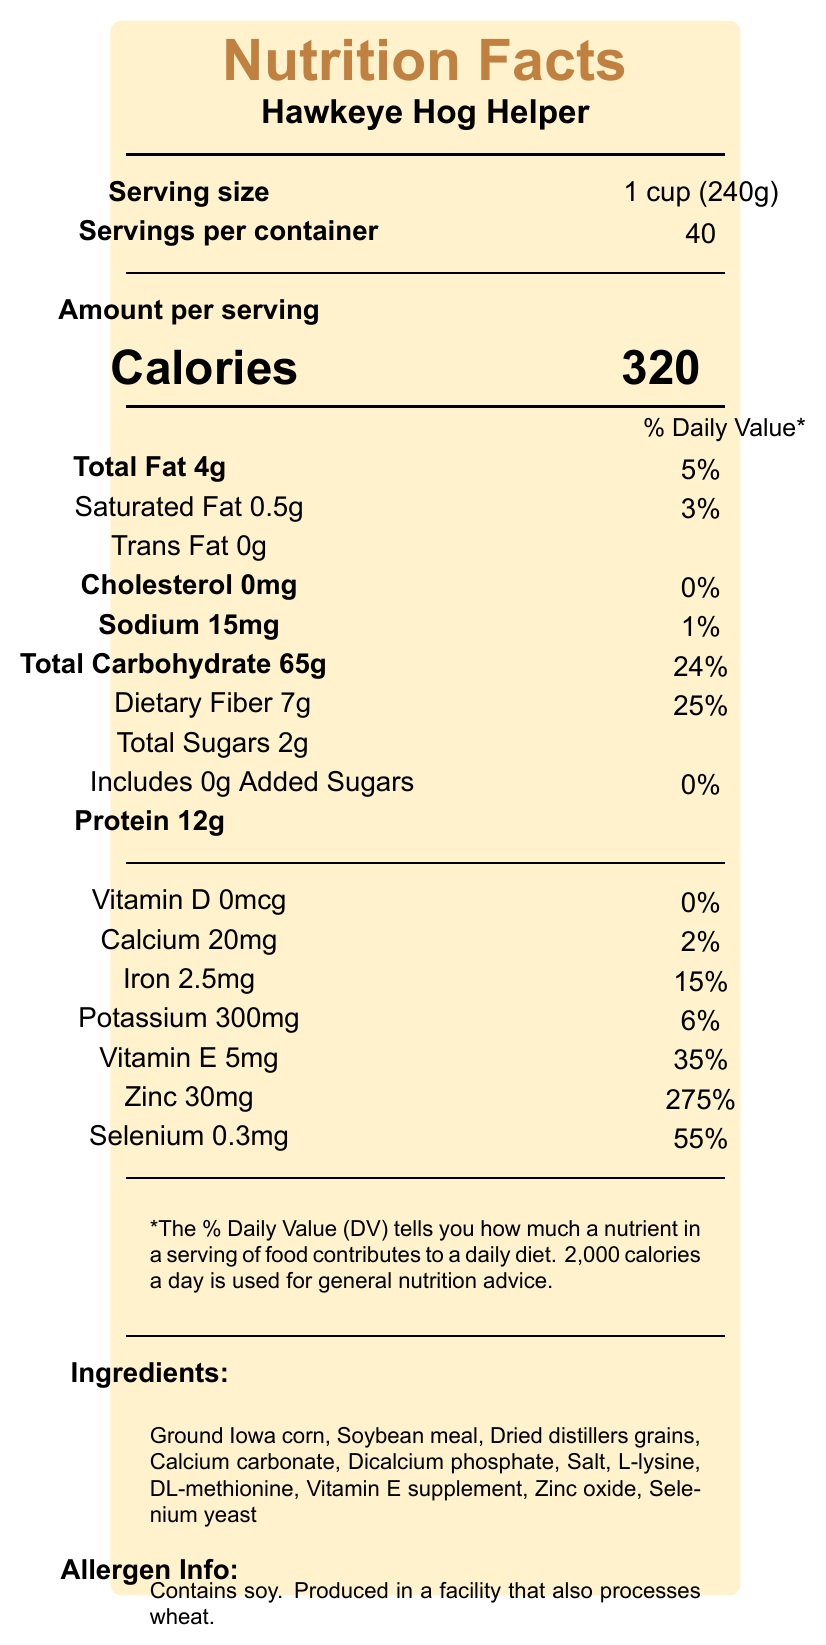what is the serving size? The serving size is clearly mentioned under "Serving size" as 1 cup (240g).
Answer: 1 cup (240g) how many servings are there per container? The number of servings per container is listed as 40, under "Servings per container".
Answer: 40 how many calories are in one serving? Under "Calories", it states that one serving has 320 calories.
Answer: 320 what is the total carbohydrate content per serving? The document lists the total carbohydrate per serving as 65g.
Answer: 65g what is the percentage daily value of iron? The percentage daily value for iron is listed as 15%.
Answer: 15% what ingredients are included in this product? The ingredients are listed at the bottom of the document under "Ingredients".
Answer: Ground Iowa corn, Soybean meal, Dried distillers grains, Calcium carbonate, Dicalcium phosphate, Salt, L-lysine, DL-methionine, Vitamin E supplement, Zinc oxide, Selenium yeast which ingredient is likely to cause an allergic reaction? A. Ground Iowa corn B. Soybean meal C. Dried distillers grains The "Allergen Info" section states that the product contains soy, which is present in the soybean meal.
Answer: B. Soybean meal what is the daily value percentage for zinc? A. 55% B. 35% C. 275% The document states that the daily value percentage for zinc is 275%.
Answer: C. 275% does this product contain any trans fat? Trans fat is listed as 0g.
Answer: No can the document help determine the cost of the product? The document does not include any information on the cost of the product.
Answer: Cannot be determined how should this product be stored? The "Storage" section advises how to store the product.
Answer: Store in a cool, dry place. Keep out of reach of children and pets. summarize the main purpose of this document. This document serves to inform consumers about the nutritional content, ingredient list, allergens, and proper storage of the Hawkeye Hog Helper pig feed supplement.
Answer: The document provides the nutritional information, ingredients, and storage instructions for the Hawkeye Hog Helper pig feed supplement. 